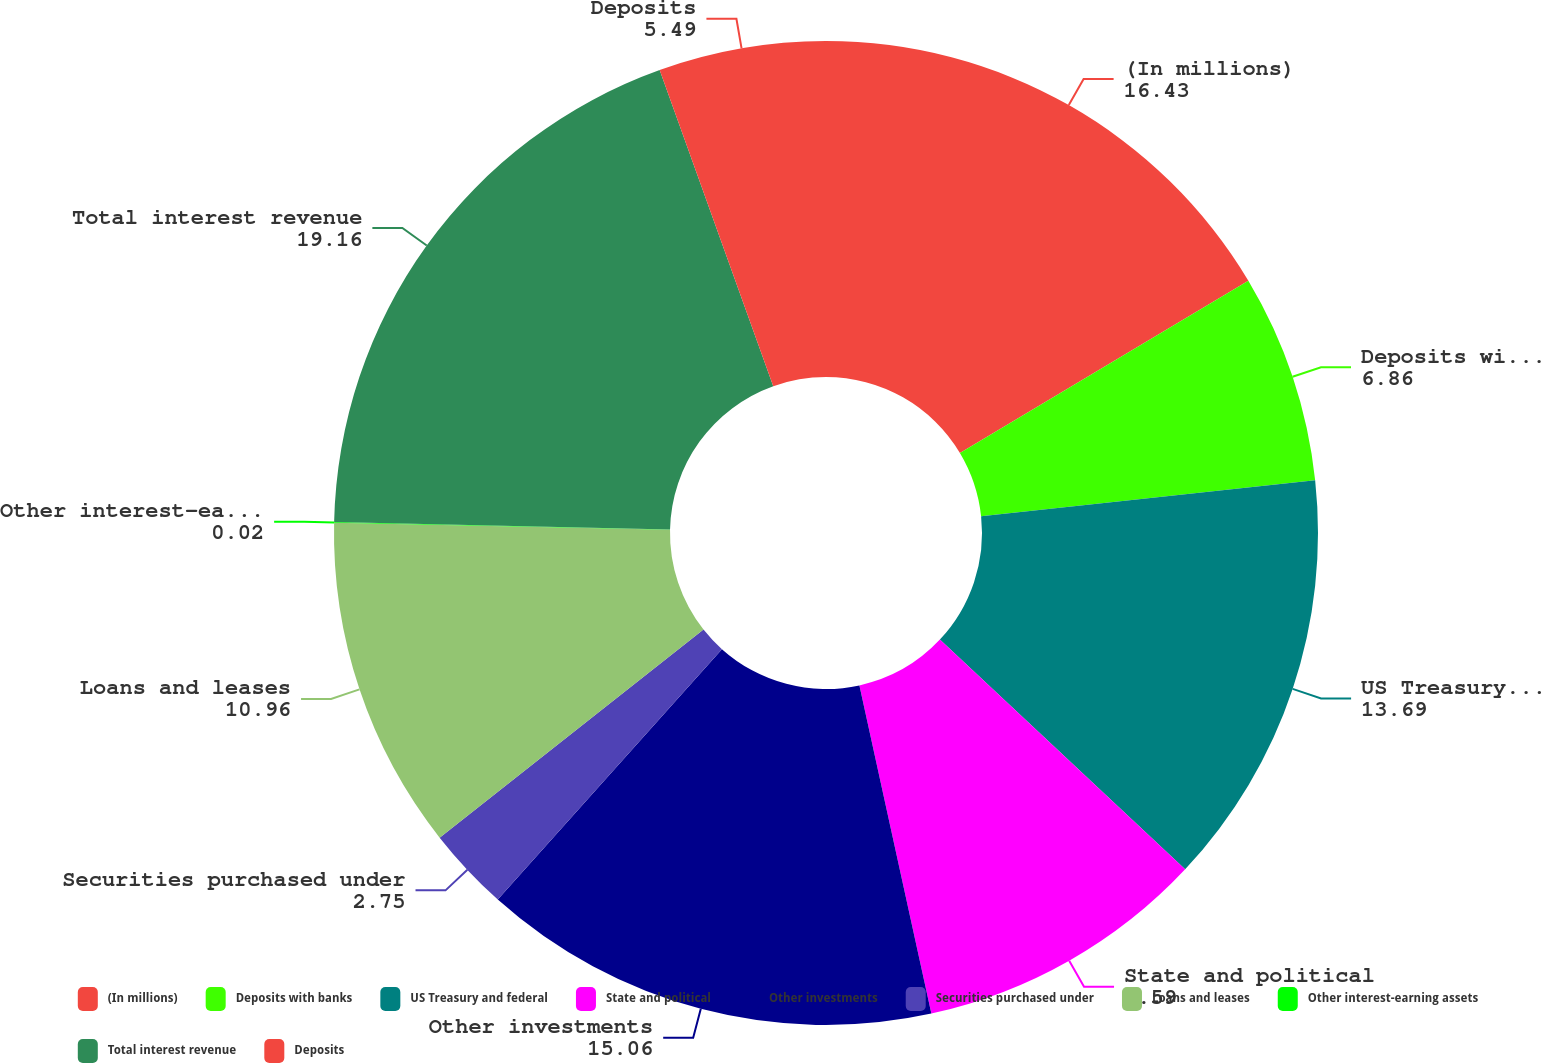Convert chart. <chart><loc_0><loc_0><loc_500><loc_500><pie_chart><fcel>(In millions)<fcel>Deposits with banks<fcel>US Treasury and federal<fcel>State and political<fcel>Other investments<fcel>Securities purchased under<fcel>Loans and leases<fcel>Other interest-earning assets<fcel>Total interest revenue<fcel>Deposits<nl><fcel>16.43%<fcel>6.86%<fcel>13.69%<fcel>9.59%<fcel>15.06%<fcel>2.75%<fcel>10.96%<fcel>0.02%<fcel>19.16%<fcel>5.49%<nl></chart> 